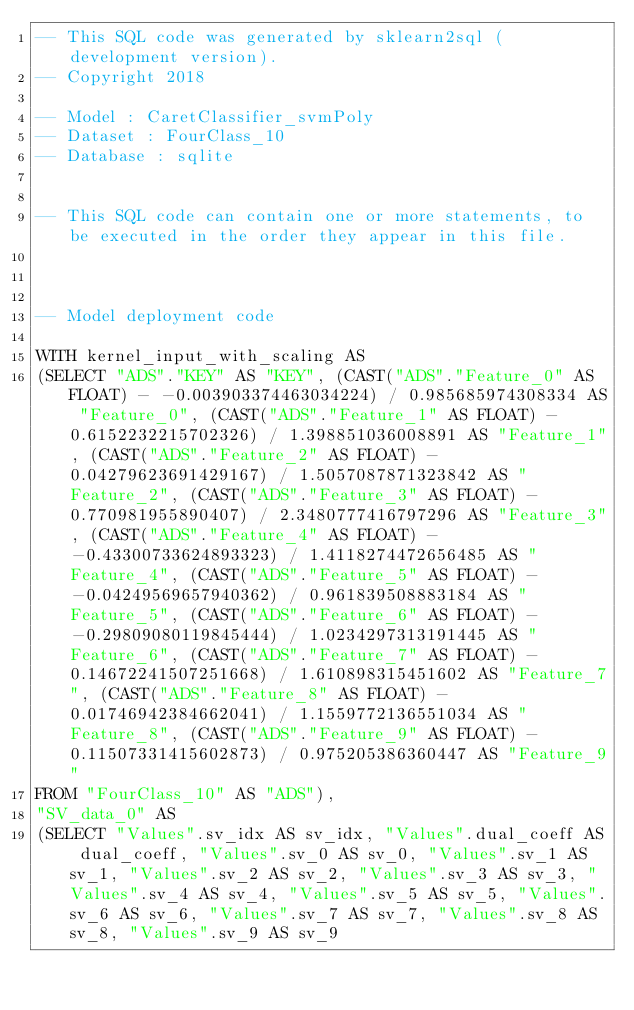<code> <loc_0><loc_0><loc_500><loc_500><_SQL_>-- This SQL code was generated by sklearn2sql (development version).
-- Copyright 2018

-- Model : CaretClassifier_svmPoly
-- Dataset : FourClass_10
-- Database : sqlite


-- This SQL code can contain one or more statements, to be executed in the order they appear in this file.



-- Model deployment code

WITH kernel_input_with_scaling AS 
(SELECT "ADS"."KEY" AS "KEY", (CAST("ADS"."Feature_0" AS FLOAT) - -0.003903374463034224) / 0.985685974308334 AS "Feature_0", (CAST("ADS"."Feature_1" AS FLOAT) - 0.6152232215702326) / 1.398851036008891 AS "Feature_1", (CAST("ADS"."Feature_2" AS FLOAT) - 0.04279623691429167) / 1.5057087871323842 AS "Feature_2", (CAST("ADS"."Feature_3" AS FLOAT) - 0.770981955890407) / 2.3480777416797296 AS "Feature_3", (CAST("ADS"."Feature_4" AS FLOAT) - -0.43300733624893323) / 1.4118274472656485 AS "Feature_4", (CAST("ADS"."Feature_5" AS FLOAT) - -0.04249569657940362) / 0.961839508883184 AS "Feature_5", (CAST("ADS"."Feature_6" AS FLOAT) - -0.29809080119845444) / 1.0234297313191445 AS "Feature_6", (CAST("ADS"."Feature_7" AS FLOAT) - 0.14672241507251668) / 1.610898315451602 AS "Feature_7", (CAST("ADS"."Feature_8" AS FLOAT) - 0.01746942384662041) / 1.1559772136551034 AS "Feature_8", (CAST("ADS"."Feature_9" AS FLOAT) - 0.11507331415602873) / 0.975205386360447 AS "Feature_9" 
FROM "FourClass_10" AS "ADS"), 
"SV_data_0" AS 
(SELECT "Values".sv_idx AS sv_idx, "Values".dual_coeff AS dual_coeff, "Values".sv_0 AS sv_0, "Values".sv_1 AS sv_1, "Values".sv_2 AS sv_2, "Values".sv_3 AS sv_3, "Values".sv_4 AS sv_4, "Values".sv_5 AS sv_5, "Values".sv_6 AS sv_6, "Values".sv_7 AS sv_7, "Values".sv_8 AS sv_8, "Values".sv_9 AS sv_9 </code> 